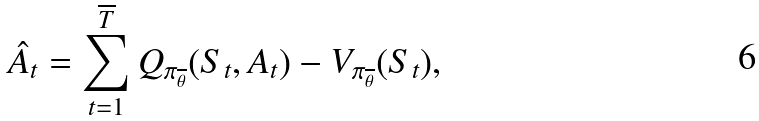Convert formula to latex. <formula><loc_0><loc_0><loc_500><loc_500>\hat { A } _ { t } = \sum _ { t = 1 } ^ { \overline { T } } Q _ { \pi _ { \overline { \theta } } } ( S _ { t } , A _ { t } ) - V _ { \pi _ { \overline { \theta } } } ( S _ { t } ) ,</formula> 